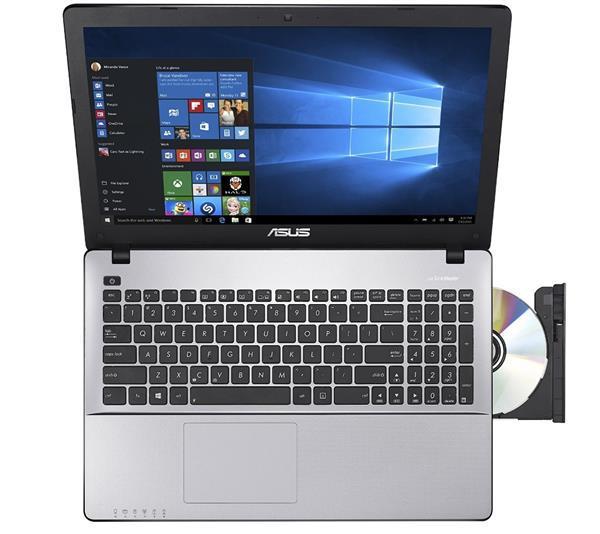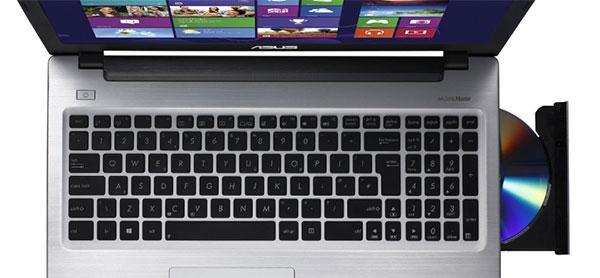The first image is the image on the left, the second image is the image on the right. Considering the images on both sides, is "The three gray laptops have an open disc drive on the right side of the keyboard." valid? Answer yes or no. Yes. The first image is the image on the left, the second image is the image on the right. Examine the images to the left and right. Is the description "The open laptop on the right is shown in an aerial view with a CD sticking out of the side, while the laptop on the left does not have a CD sticking out." accurate? Answer yes or no. No. 